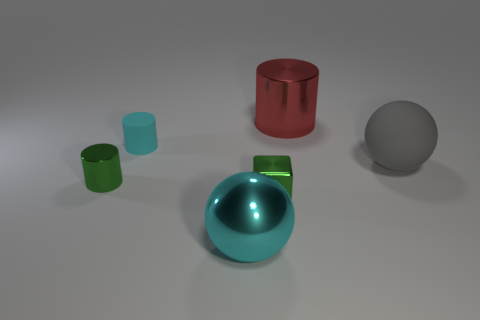Subtract all matte cylinders. How many cylinders are left? 2 Add 3 large spheres. How many objects exist? 9 Subtract 1 cylinders. How many cylinders are left? 2 Subtract all cubes. How many objects are left? 5 Subtract all brown cylinders. Subtract all yellow balls. How many cylinders are left? 3 Add 1 green metallic cubes. How many green metallic cubes exist? 2 Subtract 0 brown spheres. How many objects are left? 6 Subtract all tiny cyan matte blocks. Subtract all big gray rubber spheres. How many objects are left? 5 Add 2 metal spheres. How many metal spheres are left? 3 